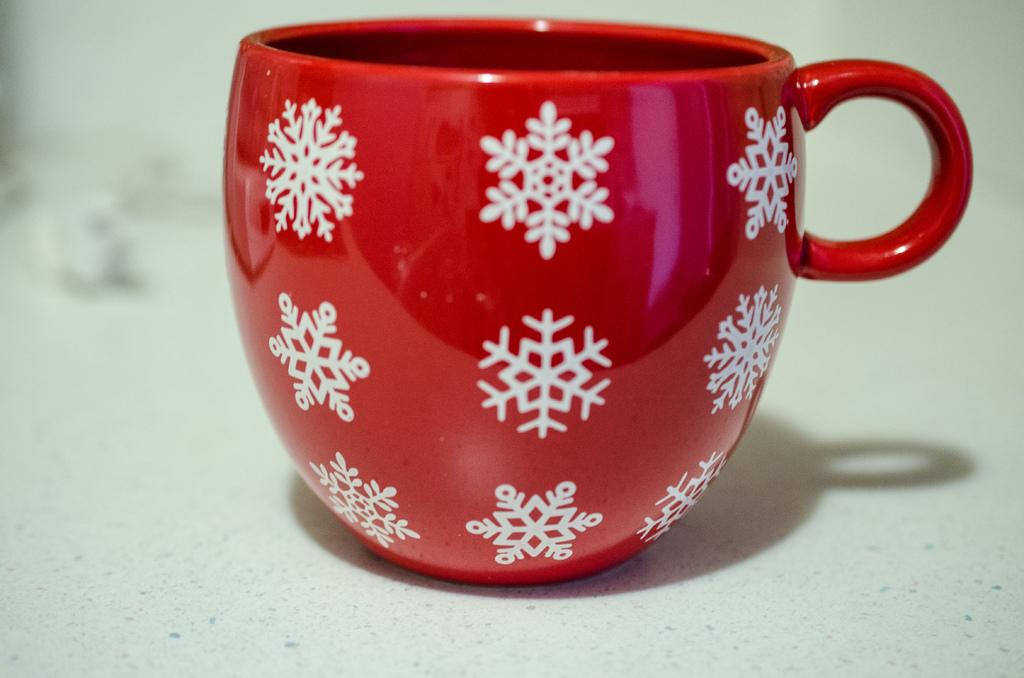What color is the cup that is visible in the image? The cup is red. What design can be seen on the cup? The cup has a white design on it. What is the color of the surface on which the cup is placed? The cup is on a white surface. Is the crib visible in the image? There is no crib present in the image. 